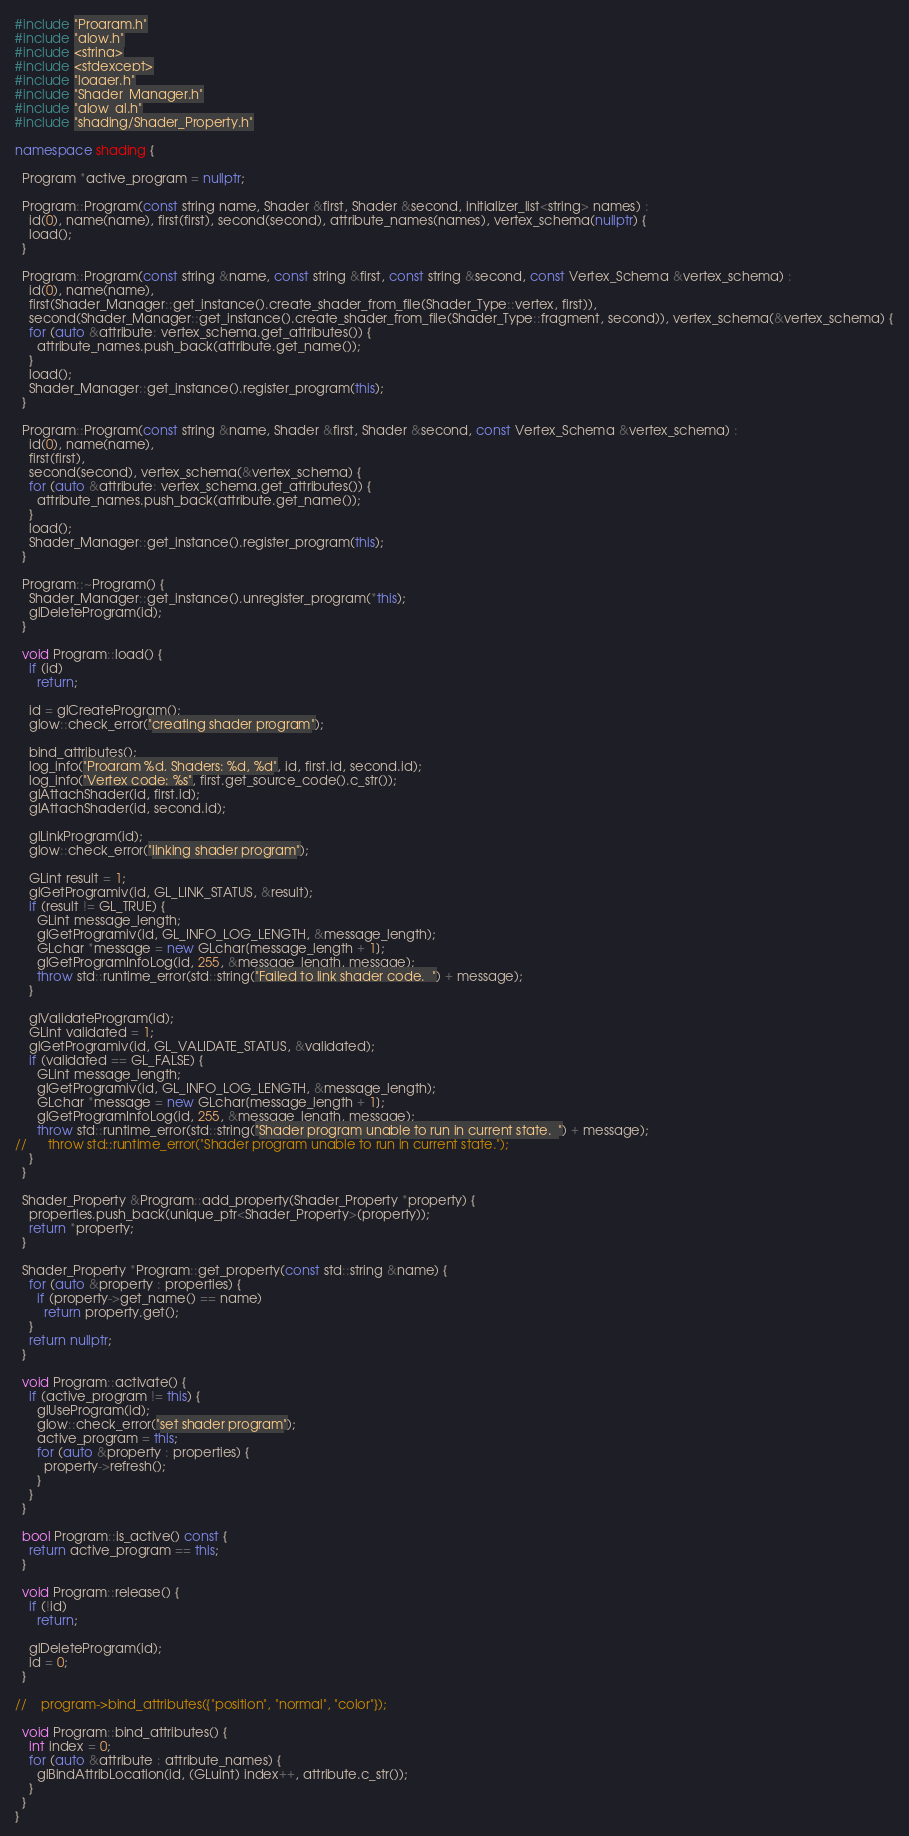<code> <loc_0><loc_0><loc_500><loc_500><_C++_>#include "Program.h"
#include "glow.h"
#include <string>
#include <stdexcept>
#include "logger.h"
#include "Shader_Manager.h"
#include "glow_gl.h"
#include "shading/Shader_Property.h"

namespace shading {

  Program *active_program = nullptr;

  Program::Program(const string name, Shader &first, Shader &second, initializer_list<string> names) :
    id(0), name(name), first(first), second(second), attribute_names(names), vertex_schema(nullptr) {
    load();
  }

  Program::Program(const string &name, const string &first, const string &second, const Vertex_Schema &vertex_schema) :
    id(0), name(name),
    first(Shader_Manager::get_instance().create_shader_from_file(Shader_Type::vertex, first)),
    second(Shader_Manager::get_instance().create_shader_from_file(Shader_Type::fragment, second)), vertex_schema(&vertex_schema) {
    for (auto &attribute: vertex_schema.get_attributes()) {
      attribute_names.push_back(attribute.get_name());
    }
    load();
    Shader_Manager::get_instance().register_program(this);
  }

  Program::Program(const string &name, Shader &first, Shader &second, const Vertex_Schema &vertex_schema) :
    id(0), name(name),
    first(first),
    second(second), vertex_schema(&vertex_schema) {
    for (auto &attribute: vertex_schema.get_attributes()) {
      attribute_names.push_back(attribute.get_name());
    }
    load();
    Shader_Manager::get_instance().register_program(this);
  }

  Program::~Program() {
    Shader_Manager::get_instance().unregister_program(*this);
    glDeleteProgram(id);
  }

  void Program::load() {
    if (id)
      return;

    id = glCreateProgram();
    glow::check_error("creating shader program");

    bind_attributes();
    log_info("Program %d, Shaders: %d, %d", id, first.id, second.id);
    log_info("Vertex code: %s", first.get_source_code().c_str());
    glAttachShader(id, first.id);
    glAttachShader(id, second.id);

    glLinkProgram(id);
    glow::check_error("linking shader program");

    GLint result = 1;
    glGetProgramiv(id, GL_LINK_STATUS, &result);
    if (result != GL_TRUE) {
      GLint message_length;
      glGetProgramiv(id, GL_INFO_LOG_LENGTH, &message_length);
      GLchar *message = new GLchar[message_length + 1];
      glGetProgramInfoLog(id, 255, &message_length, message);
      throw std::runtime_error(std::string("Failed to link shader code.  ") + message);
    }

    glValidateProgram(id);
    GLint validated = 1;
    glGetProgramiv(id, GL_VALIDATE_STATUS, &validated);
    if (validated == GL_FALSE) {
      GLint message_length;
      glGetProgramiv(id, GL_INFO_LOG_LENGTH, &message_length);
      GLchar *message = new GLchar[message_length + 1];
      glGetProgramInfoLog(id, 255, &message_length, message);
      throw std::runtime_error(std::string("Shader program unable to run in current state.  ") + message);
//      throw std::runtime_error("Shader program unable to run in current state.");
    }
  }

  Shader_Property &Program::add_property(Shader_Property *property) {
    properties.push_back(unique_ptr<Shader_Property>(property));
    return *property;
  }

  Shader_Property *Program::get_property(const std::string &name) {
    for (auto &property : properties) {
      if (property->get_name() == name)
        return property.get();
    }
    return nullptr;
  }

  void Program::activate() {
    if (active_program != this) {
      glUseProgram(id);
      glow::check_error("set shader program");
      active_program = this;
      for (auto &property : properties) {
        property->refresh();
      }
    }
  }

  bool Program::is_active() const {
    return active_program == this;
  }

  void Program::release() {
    if (!id)
      return;

    glDeleteProgram(id);
    id = 0;
  }

//    program->bind_attributes({"position", "normal", "color"});

  void Program::bind_attributes() {
    int index = 0;
    for (auto &attribute : attribute_names) {
      glBindAttribLocation(id, (GLuint) index++, attribute.c_str());
    }
  }
}
</code> 